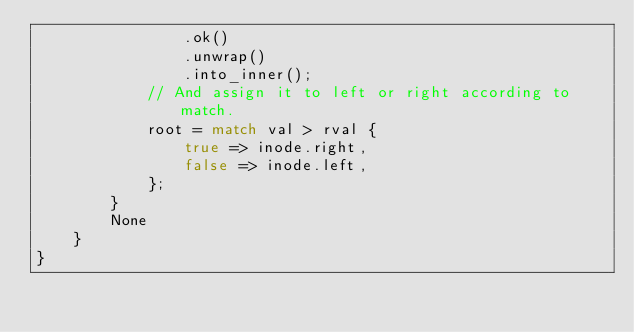Convert code to text. <code><loc_0><loc_0><loc_500><loc_500><_Rust_>                .ok()
                .unwrap()
                .into_inner();
            // And assign it to left or right according to match.
            root = match val > rval {
                true => inode.right,
                false => inode.left,
            };
        }
        None
    }
}
</code> 